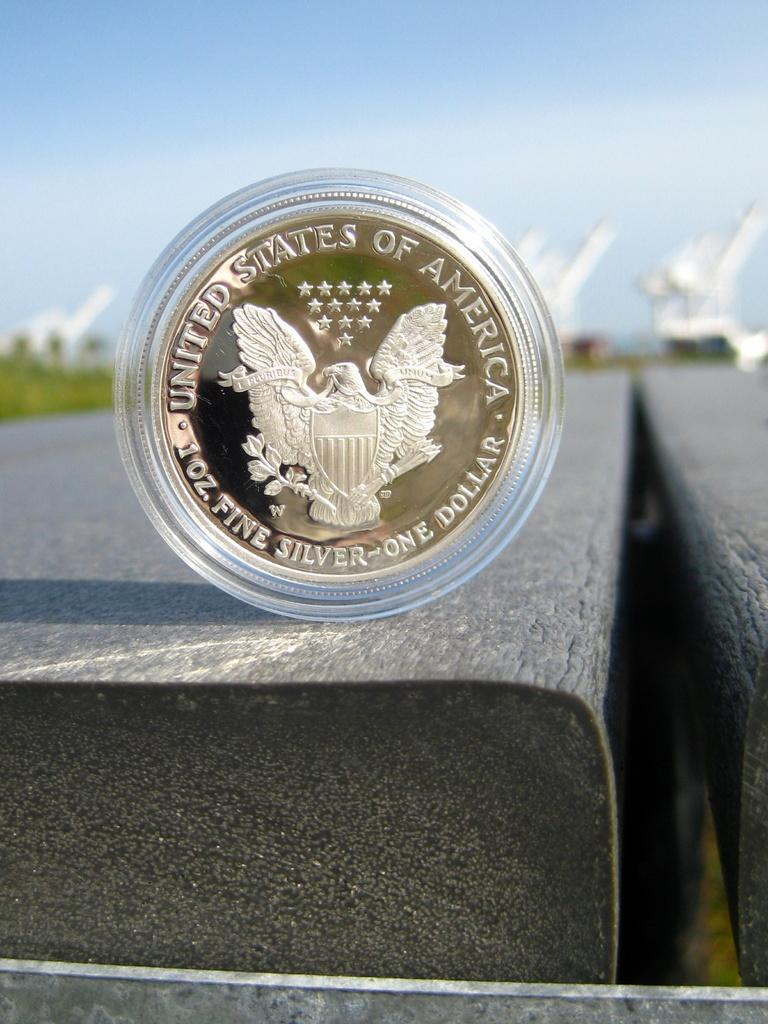Provide a one-sentence caption for the provided image. A coin for one dollar and 1 oz. fine silver. 